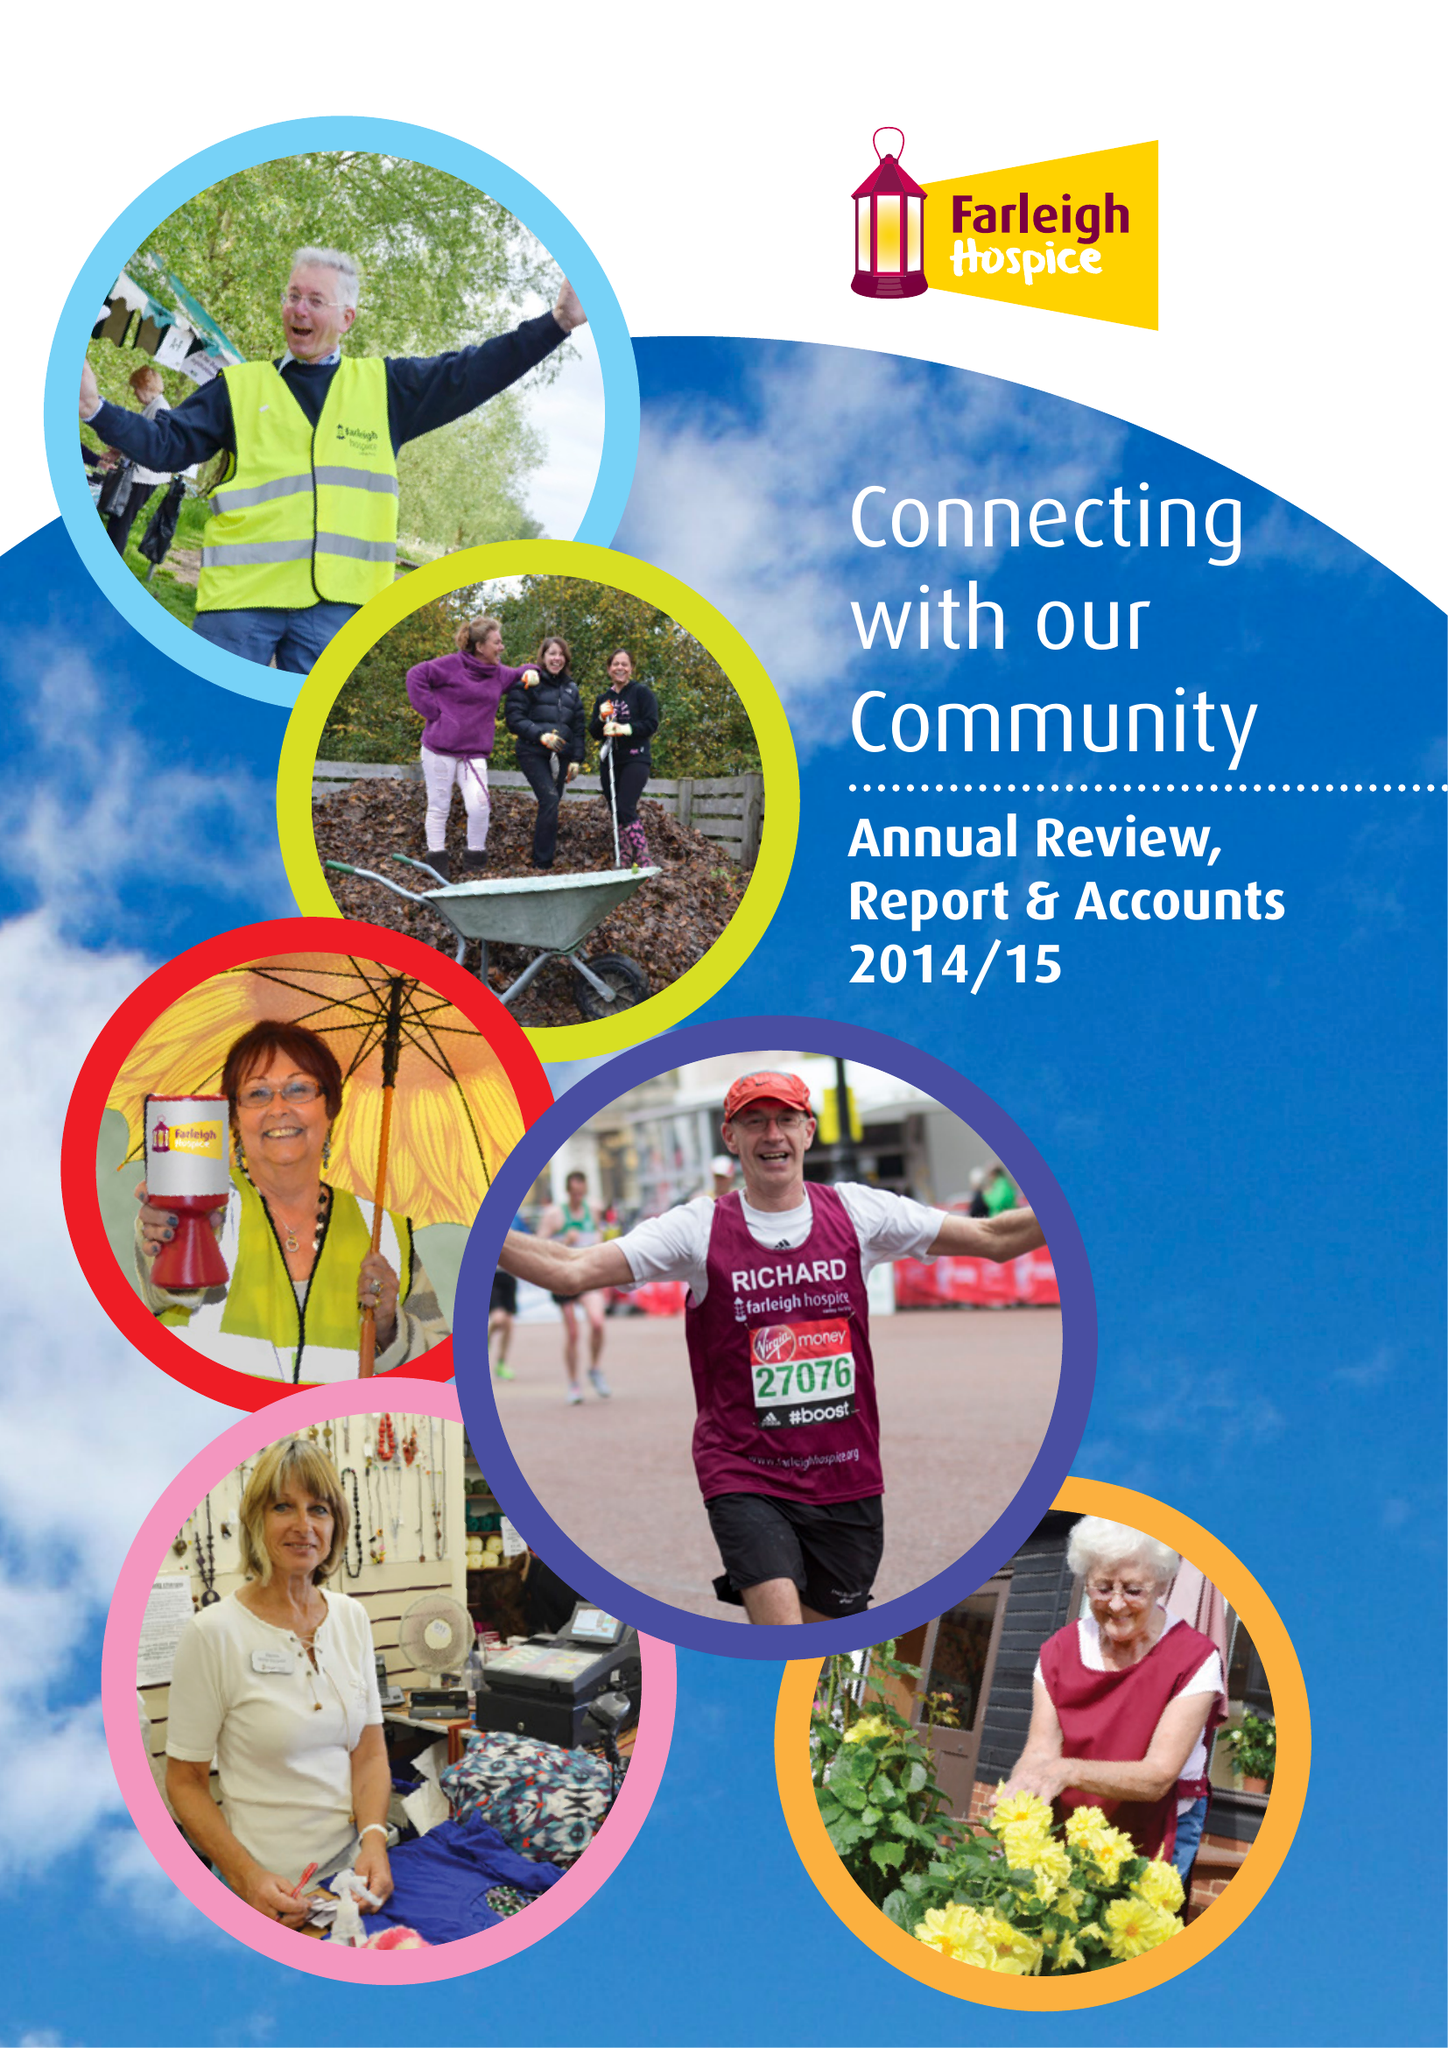What is the value for the address__street_line?
Answer the question using a single word or phrase. NORTH COURT ROAD 